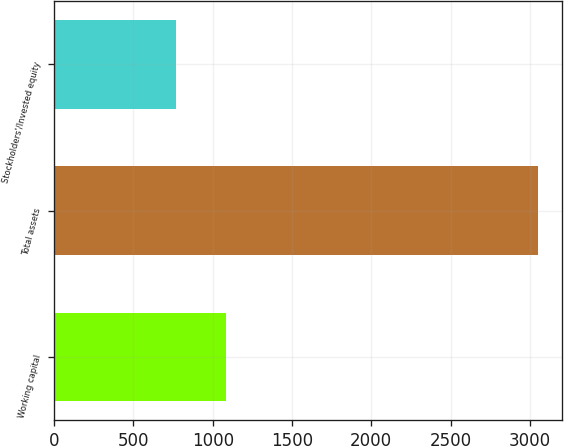Convert chart. <chart><loc_0><loc_0><loc_500><loc_500><bar_chart><fcel>Working capital<fcel>Total assets<fcel>Stockholders'/Invested equity<nl><fcel>1081<fcel>3050<fcel>769<nl></chart> 